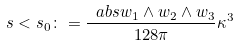<formula> <loc_0><loc_0><loc_500><loc_500>s < s _ { 0 } \colon = \frac { \ a b s { w _ { 1 } \wedge w _ { 2 } \wedge w _ { 3 } } } { 1 2 8 \pi } \kappa ^ { 3 }</formula> 